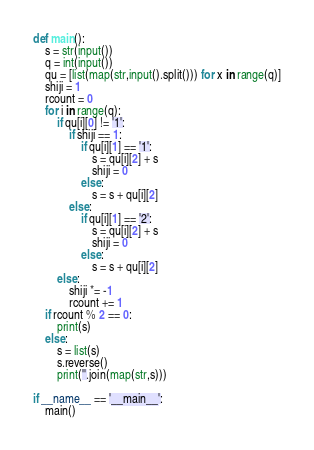Convert code to text. <code><loc_0><loc_0><loc_500><loc_500><_Python_>def main():
	s = str(input())
	q = int(input())
	qu = [list(map(str,input().split())) for x in range(q)]
	shiji = 1
	rcount = 0
	for i in range(q):
		if qu[i][0] != '1':
			if shiji == 1:
				if qu[i][1] == '1':
					s = qu[i][2] + s
					shiji = 0
				else:
					s = s + qu[i][2]
			else:
				if qu[i][1] == '2':
					s = qu[i][2] + s
					shiji = 0
				else:
					s = s + qu[i][2]
		else:
			shiji *= -1
			rcount += 1
	if rcount % 2 == 0:
		print(s)
	else:
		s = list(s)
		s.reverse()
		print(''.join(map(str,s)))

if __name__ == '__main__':
	main()</code> 